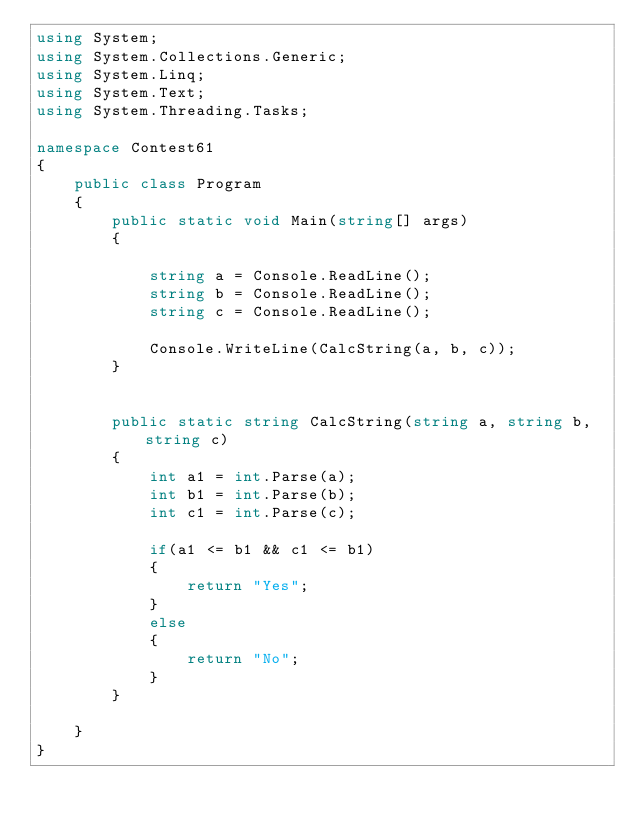<code> <loc_0><loc_0><loc_500><loc_500><_C#_>using System;
using System.Collections.Generic;
using System.Linq;
using System.Text;
using System.Threading.Tasks;

namespace Contest61
{
    public class Program
    {
        public static void Main(string[] args)
        {

            string a = Console.ReadLine();
            string b = Console.ReadLine();
            string c = Console.ReadLine();

            Console.WriteLine(CalcString(a, b, c));
        }


        public static string CalcString(string a, string b, string c)
        {
            int a1 = int.Parse(a);
            int b1 = int.Parse(b);
            int c1 = int.Parse(c);

            if(a1 <= b1 && c1 <= b1)
            {
                return "Yes";
            }
            else
            {
                return "No";
            }
        }

    }
}
</code> 